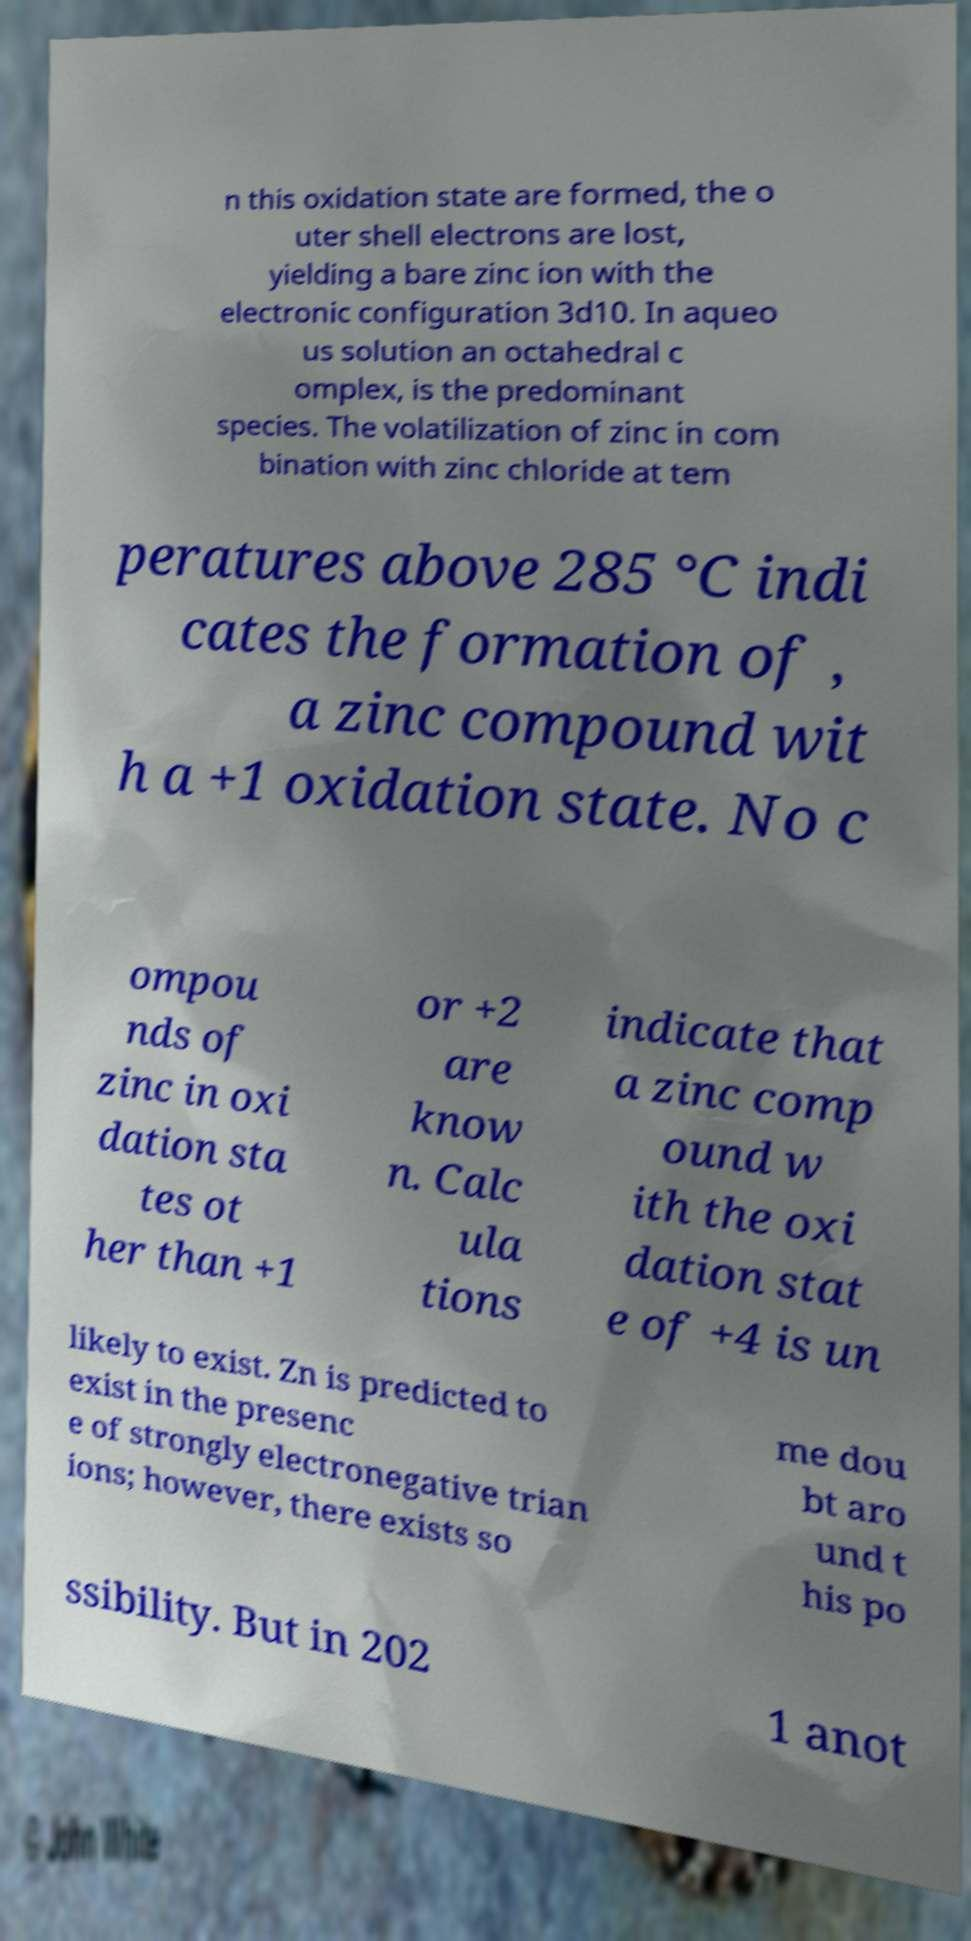Could you assist in decoding the text presented in this image and type it out clearly? n this oxidation state are formed, the o uter shell electrons are lost, yielding a bare zinc ion with the electronic configuration 3d10. In aqueo us solution an octahedral c omplex, is the predominant species. The volatilization of zinc in com bination with zinc chloride at tem peratures above 285 °C indi cates the formation of , a zinc compound wit h a +1 oxidation state. No c ompou nds of zinc in oxi dation sta tes ot her than +1 or +2 are know n. Calc ula tions indicate that a zinc comp ound w ith the oxi dation stat e of +4 is un likely to exist. Zn is predicted to exist in the presenc e of strongly electronegative trian ions; however, there exists so me dou bt aro und t his po ssibility. But in 202 1 anot 